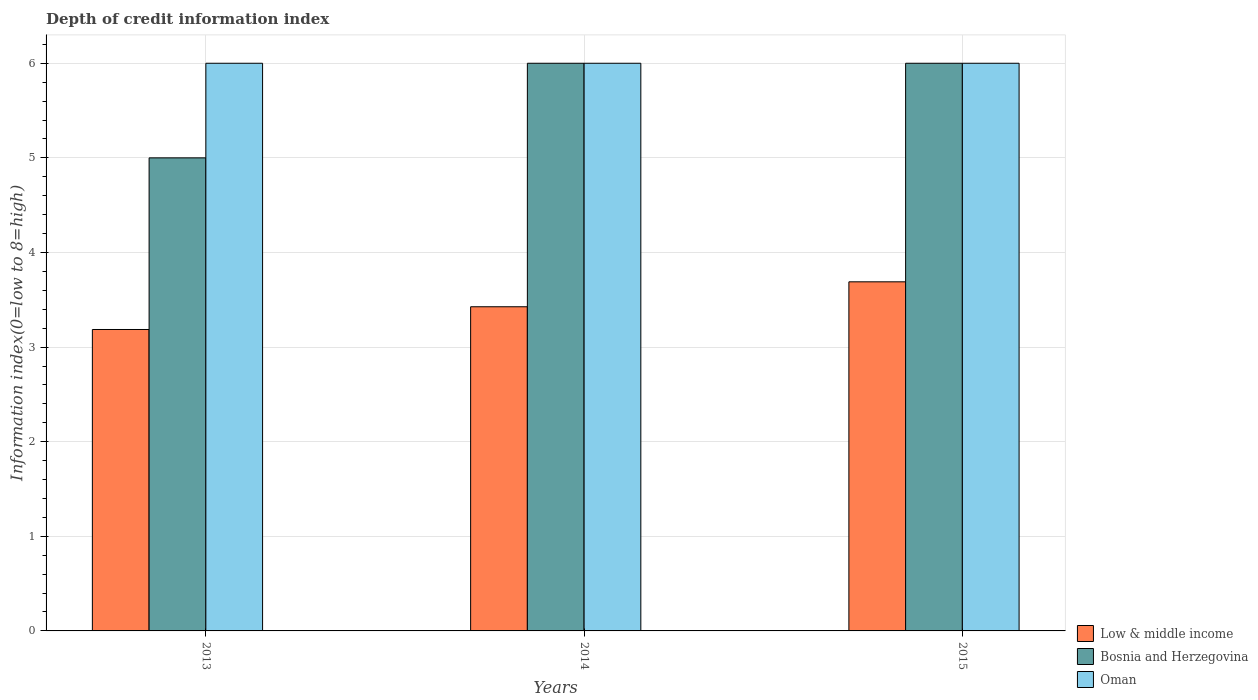How many groups of bars are there?
Provide a short and direct response. 3. Are the number of bars per tick equal to the number of legend labels?
Your response must be concise. Yes. Are the number of bars on each tick of the X-axis equal?
Make the answer very short. Yes. How many bars are there on the 3rd tick from the left?
Provide a short and direct response. 3. How many bars are there on the 2nd tick from the right?
Your answer should be very brief. 3. In how many cases, is the number of bars for a given year not equal to the number of legend labels?
Make the answer very short. 0. What is the information index in Bosnia and Herzegovina in 2013?
Give a very brief answer. 5. Across all years, what is the maximum information index in Bosnia and Herzegovina?
Your answer should be very brief. 6. In which year was the information index in Bosnia and Herzegovina maximum?
Your response must be concise. 2014. What is the total information index in Bosnia and Herzegovina in the graph?
Make the answer very short. 17. What is the difference between the information index in Bosnia and Herzegovina in 2015 and the information index in Low & middle income in 2013?
Keep it short and to the point. 2.81. What is the average information index in Oman per year?
Provide a short and direct response. 6. In the year 2013, what is the difference between the information index in Low & middle income and information index in Oman?
Offer a very short reply. -2.81. Is the difference between the information index in Low & middle income in 2013 and 2015 greater than the difference between the information index in Oman in 2013 and 2015?
Your response must be concise. No. What is the difference between the highest and the second highest information index in Oman?
Your answer should be compact. 0. What is the difference between the highest and the lowest information index in Low & middle income?
Offer a very short reply. 0.5. In how many years, is the information index in Low & middle income greater than the average information index in Low & middle income taken over all years?
Your response must be concise. 1. What does the 2nd bar from the right in 2013 represents?
Offer a terse response. Bosnia and Herzegovina. Is it the case that in every year, the sum of the information index in Low & middle income and information index in Bosnia and Herzegovina is greater than the information index in Oman?
Offer a very short reply. Yes. How many bars are there?
Your response must be concise. 9. What is the difference between two consecutive major ticks on the Y-axis?
Give a very brief answer. 1. Does the graph contain grids?
Keep it short and to the point. Yes. How are the legend labels stacked?
Offer a very short reply. Vertical. What is the title of the graph?
Provide a short and direct response. Depth of credit information index. What is the label or title of the X-axis?
Provide a succinct answer. Years. What is the label or title of the Y-axis?
Keep it short and to the point. Information index(0=low to 8=high). What is the Information index(0=low to 8=high) of Low & middle income in 2013?
Give a very brief answer. 3.19. What is the Information index(0=low to 8=high) in Bosnia and Herzegovina in 2013?
Offer a terse response. 5. What is the Information index(0=low to 8=high) of Oman in 2013?
Your answer should be very brief. 6. What is the Information index(0=low to 8=high) of Low & middle income in 2014?
Offer a terse response. 3.43. What is the Information index(0=low to 8=high) in Bosnia and Herzegovina in 2014?
Ensure brevity in your answer.  6. What is the Information index(0=low to 8=high) in Oman in 2014?
Provide a short and direct response. 6. What is the Information index(0=low to 8=high) of Low & middle income in 2015?
Keep it short and to the point. 3.69. Across all years, what is the maximum Information index(0=low to 8=high) of Low & middle income?
Your answer should be very brief. 3.69. Across all years, what is the minimum Information index(0=low to 8=high) in Low & middle income?
Provide a succinct answer. 3.19. Across all years, what is the minimum Information index(0=low to 8=high) of Bosnia and Herzegovina?
Provide a succinct answer. 5. Across all years, what is the minimum Information index(0=low to 8=high) in Oman?
Offer a terse response. 6. What is the total Information index(0=low to 8=high) of Low & middle income in the graph?
Give a very brief answer. 10.3. What is the total Information index(0=low to 8=high) of Bosnia and Herzegovina in the graph?
Keep it short and to the point. 17. What is the total Information index(0=low to 8=high) in Oman in the graph?
Provide a succinct answer. 18. What is the difference between the Information index(0=low to 8=high) in Low & middle income in 2013 and that in 2014?
Provide a succinct answer. -0.24. What is the difference between the Information index(0=low to 8=high) in Bosnia and Herzegovina in 2013 and that in 2014?
Provide a short and direct response. -1. What is the difference between the Information index(0=low to 8=high) of Low & middle income in 2013 and that in 2015?
Give a very brief answer. -0.5. What is the difference between the Information index(0=low to 8=high) in Bosnia and Herzegovina in 2013 and that in 2015?
Your response must be concise. -1. What is the difference between the Information index(0=low to 8=high) in Low & middle income in 2014 and that in 2015?
Your response must be concise. -0.26. What is the difference between the Information index(0=low to 8=high) of Oman in 2014 and that in 2015?
Give a very brief answer. 0. What is the difference between the Information index(0=low to 8=high) in Low & middle income in 2013 and the Information index(0=low to 8=high) in Bosnia and Herzegovina in 2014?
Ensure brevity in your answer.  -2.81. What is the difference between the Information index(0=low to 8=high) of Low & middle income in 2013 and the Information index(0=low to 8=high) of Oman in 2014?
Your response must be concise. -2.81. What is the difference between the Information index(0=low to 8=high) in Bosnia and Herzegovina in 2013 and the Information index(0=low to 8=high) in Oman in 2014?
Your answer should be very brief. -1. What is the difference between the Information index(0=low to 8=high) in Low & middle income in 2013 and the Information index(0=low to 8=high) in Bosnia and Herzegovina in 2015?
Offer a terse response. -2.81. What is the difference between the Information index(0=low to 8=high) in Low & middle income in 2013 and the Information index(0=low to 8=high) in Oman in 2015?
Provide a succinct answer. -2.81. What is the difference between the Information index(0=low to 8=high) in Low & middle income in 2014 and the Information index(0=low to 8=high) in Bosnia and Herzegovina in 2015?
Your answer should be compact. -2.57. What is the difference between the Information index(0=low to 8=high) of Low & middle income in 2014 and the Information index(0=low to 8=high) of Oman in 2015?
Provide a succinct answer. -2.57. What is the average Information index(0=low to 8=high) in Low & middle income per year?
Provide a succinct answer. 3.43. What is the average Information index(0=low to 8=high) in Bosnia and Herzegovina per year?
Ensure brevity in your answer.  5.67. What is the average Information index(0=low to 8=high) of Oman per year?
Provide a succinct answer. 6. In the year 2013, what is the difference between the Information index(0=low to 8=high) in Low & middle income and Information index(0=low to 8=high) in Bosnia and Herzegovina?
Your response must be concise. -1.81. In the year 2013, what is the difference between the Information index(0=low to 8=high) of Low & middle income and Information index(0=low to 8=high) of Oman?
Provide a succinct answer. -2.81. In the year 2013, what is the difference between the Information index(0=low to 8=high) in Bosnia and Herzegovina and Information index(0=low to 8=high) in Oman?
Your response must be concise. -1. In the year 2014, what is the difference between the Information index(0=low to 8=high) of Low & middle income and Information index(0=low to 8=high) of Bosnia and Herzegovina?
Provide a succinct answer. -2.57. In the year 2014, what is the difference between the Information index(0=low to 8=high) of Low & middle income and Information index(0=low to 8=high) of Oman?
Offer a terse response. -2.57. In the year 2014, what is the difference between the Information index(0=low to 8=high) in Bosnia and Herzegovina and Information index(0=low to 8=high) in Oman?
Ensure brevity in your answer.  0. In the year 2015, what is the difference between the Information index(0=low to 8=high) in Low & middle income and Information index(0=low to 8=high) in Bosnia and Herzegovina?
Your response must be concise. -2.31. In the year 2015, what is the difference between the Information index(0=low to 8=high) of Low & middle income and Information index(0=low to 8=high) of Oman?
Provide a short and direct response. -2.31. What is the ratio of the Information index(0=low to 8=high) in Low & middle income in 2013 to that in 2014?
Provide a succinct answer. 0.93. What is the ratio of the Information index(0=low to 8=high) of Oman in 2013 to that in 2014?
Your answer should be very brief. 1. What is the ratio of the Information index(0=low to 8=high) in Low & middle income in 2013 to that in 2015?
Offer a very short reply. 0.86. What is the ratio of the Information index(0=low to 8=high) in Bosnia and Herzegovina in 2013 to that in 2015?
Offer a terse response. 0.83. What is the ratio of the Information index(0=low to 8=high) of Bosnia and Herzegovina in 2014 to that in 2015?
Your answer should be compact. 1. What is the difference between the highest and the second highest Information index(0=low to 8=high) of Low & middle income?
Your response must be concise. 0.26. What is the difference between the highest and the second highest Information index(0=low to 8=high) of Bosnia and Herzegovina?
Keep it short and to the point. 0. What is the difference between the highest and the second highest Information index(0=low to 8=high) in Oman?
Give a very brief answer. 0. What is the difference between the highest and the lowest Information index(0=low to 8=high) in Low & middle income?
Provide a succinct answer. 0.5. What is the difference between the highest and the lowest Information index(0=low to 8=high) in Bosnia and Herzegovina?
Keep it short and to the point. 1. What is the difference between the highest and the lowest Information index(0=low to 8=high) of Oman?
Your answer should be very brief. 0. 